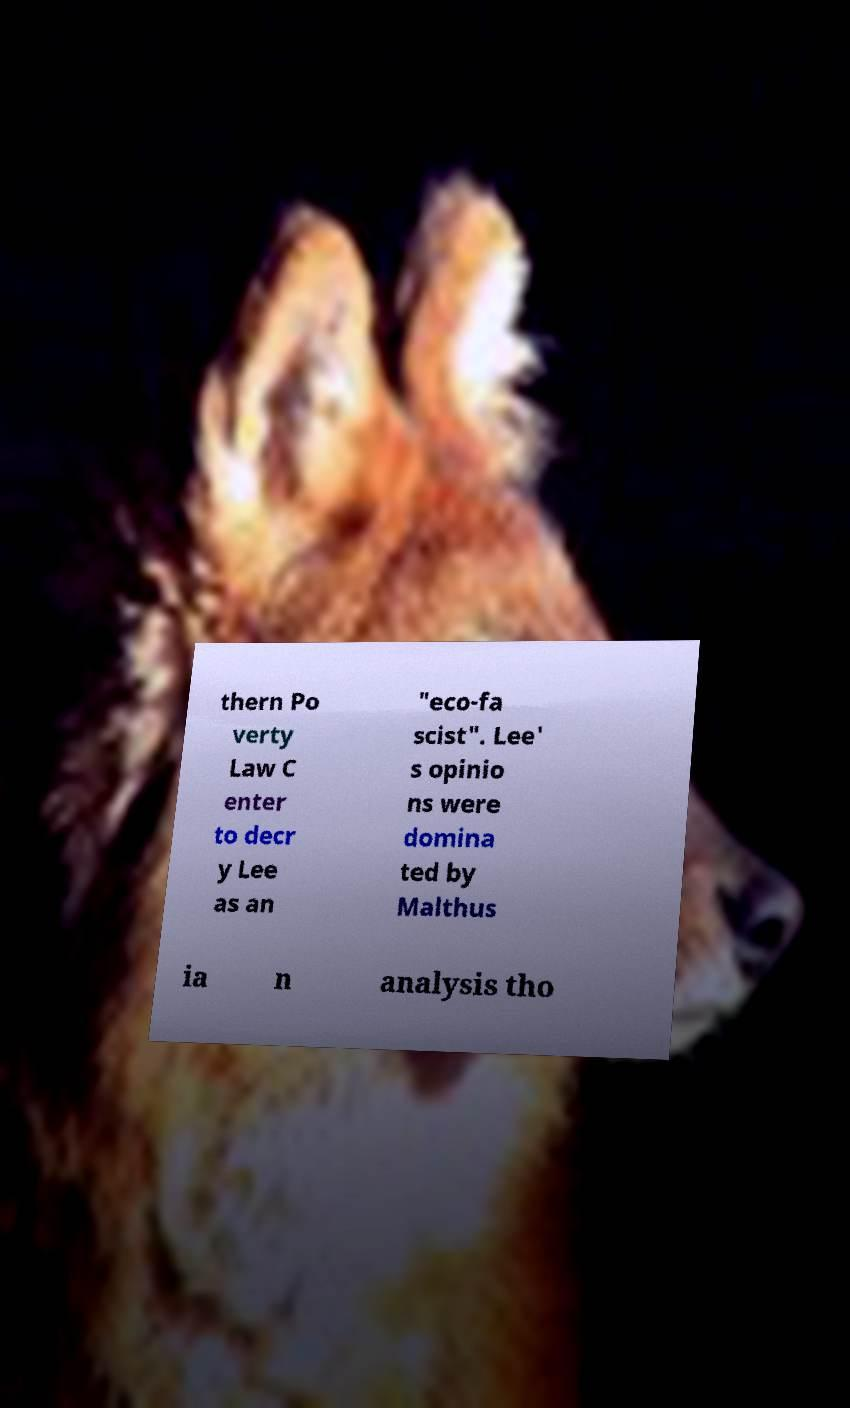For documentation purposes, I need the text within this image transcribed. Could you provide that? thern Po verty Law C enter to decr y Lee as an "eco-fa scist". Lee' s opinio ns were domina ted by Malthus ia n analysis tho 